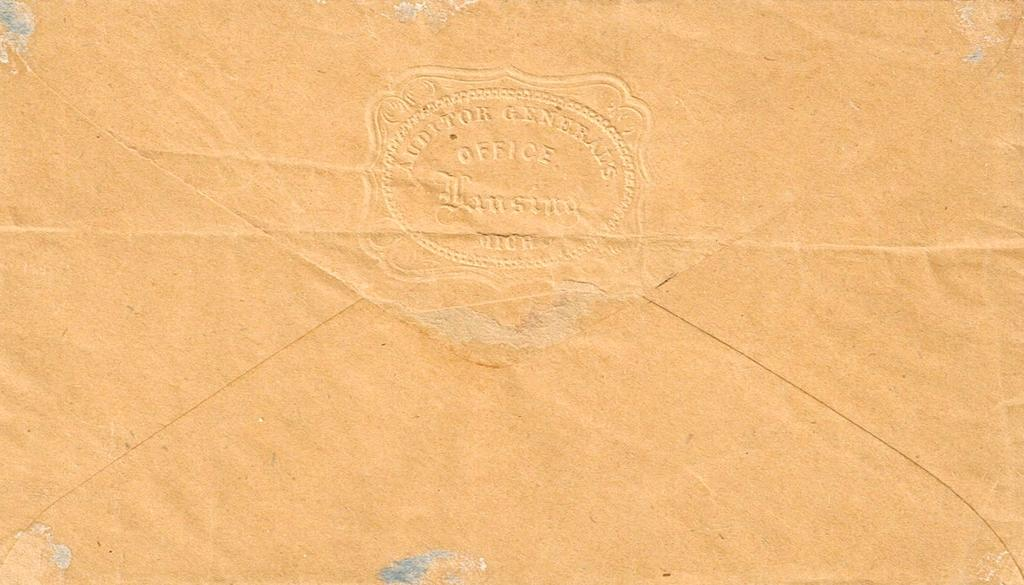<image>
Provide a brief description of the given image. An envelope is stamped on the back from the Auditor General's office. 